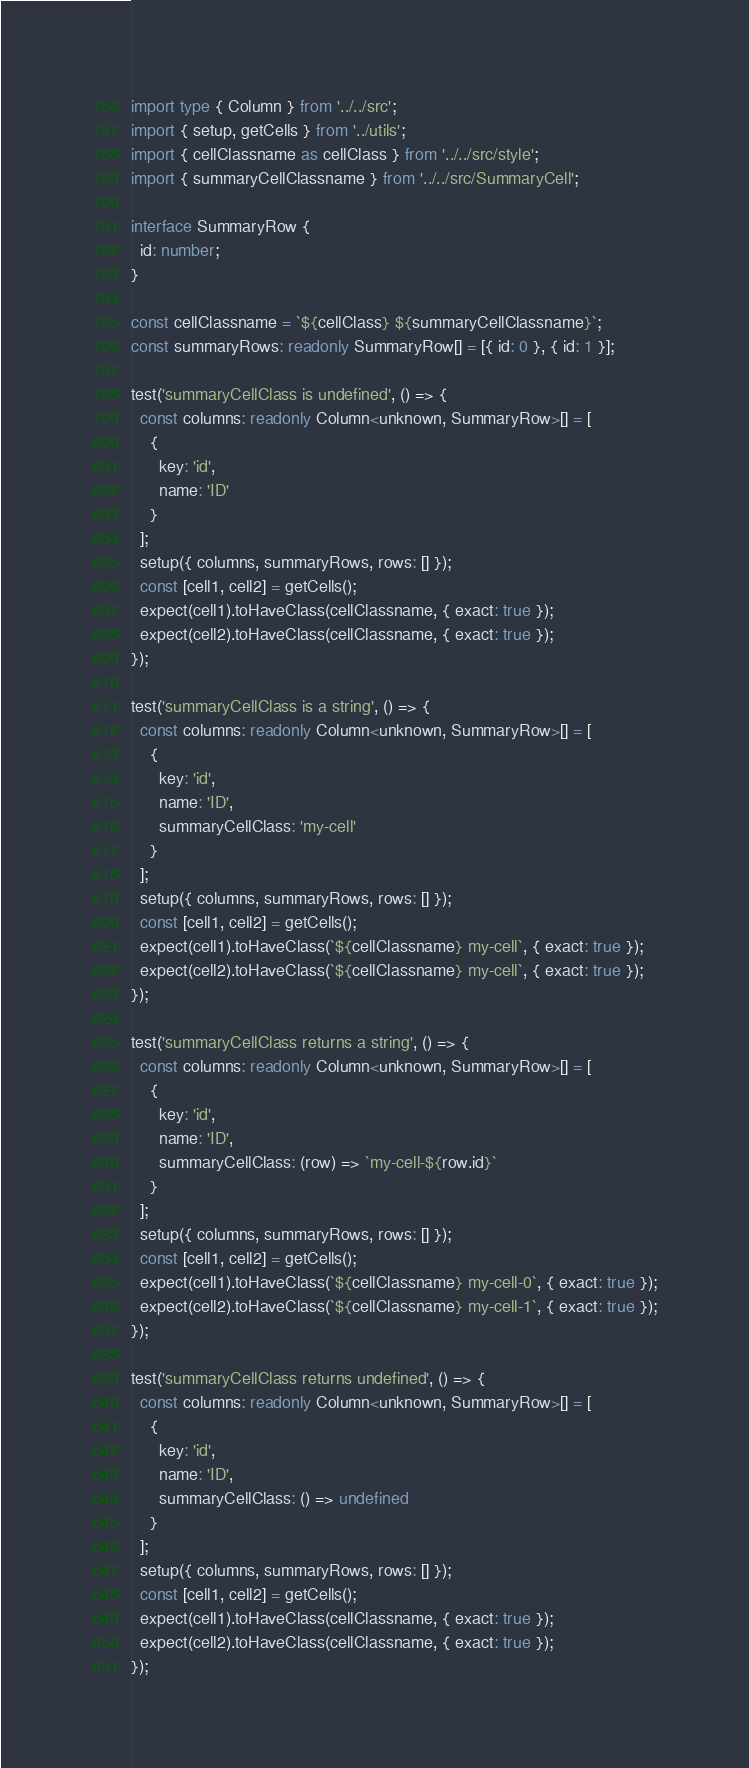<code> <loc_0><loc_0><loc_500><loc_500><_TypeScript_>import type { Column } from '../../src';
import { setup, getCells } from '../utils';
import { cellClassname as cellClass } from '../../src/style';
import { summaryCellClassname } from '../../src/SummaryCell';

interface SummaryRow {
  id: number;
}

const cellClassname = `${cellClass} ${summaryCellClassname}`;
const summaryRows: readonly SummaryRow[] = [{ id: 0 }, { id: 1 }];

test('summaryCellClass is undefined', () => {
  const columns: readonly Column<unknown, SummaryRow>[] = [
    {
      key: 'id',
      name: 'ID'
    }
  ];
  setup({ columns, summaryRows, rows: [] });
  const [cell1, cell2] = getCells();
  expect(cell1).toHaveClass(cellClassname, { exact: true });
  expect(cell2).toHaveClass(cellClassname, { exact: true });
});

test('summaryCellClass is a string', () => {
  const columns: readonly Column<unknown, SummaryRow>[] = [
    {
      key: 'id',
      name: 'ID',
      summaryCellClass: 'my-cell'
    }
  ];
  setup({ columns, summaryRows, rows: [] });
  const [cell1, cell2] = getCells();
  expect(cell1).toHaveClass(`${cellClassname} my-cell`, { exact: true });
  expect(cell2).toHaveClass(`${cellClassname} my-cell`, { exact: true });
});

test('summaryCellClass returns a string', () => {
  const columns: readonly Column<unknown, SummaryRow>[] = [
    {
      key: 'id',
      name: 'ID',
      summaryCellClass: (row) => `my-cell-${row.id}`
    }
  ];
  setup({ columns, summaryRows, rows: [] });
  const [cell1, cell2] = getCells();
  expect(cell1).toHaveClass(`${cellClassname} my-cell-0`, { exact: true });
  expect(cell2).toHaveClass(`${cellClassname} my-cell-1`, { exact: true });
});

test('summaryCellClass returns undefined', () => {
  const columns: readonly Column<unknown, SummaryRow>[] = [
    {
      key: 'id',
      name: 'ID',
      summaryCellClass: () => undefined
    }
  ];
  setup({ columns, summaryRows, rows: [] });
  const [cell1, cell2] = getCells();
  expect(cell1).toHaveClass(cellClassname, { exact: true });
  expect(cell2).toHaveClass(cellClassname, { exact: true });
});
</code> 